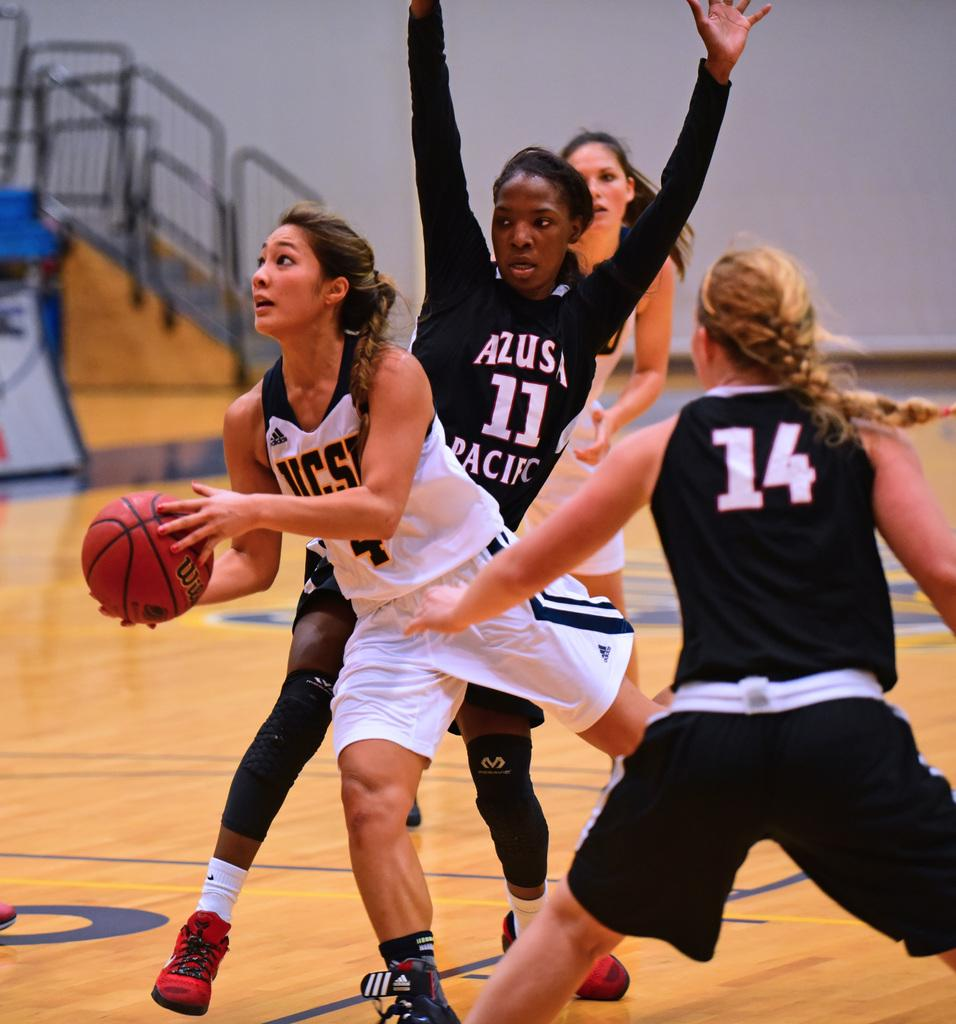<image>
Present a compact description of the photo's key features. A girl in a black uniform has the number 14 on the back. 